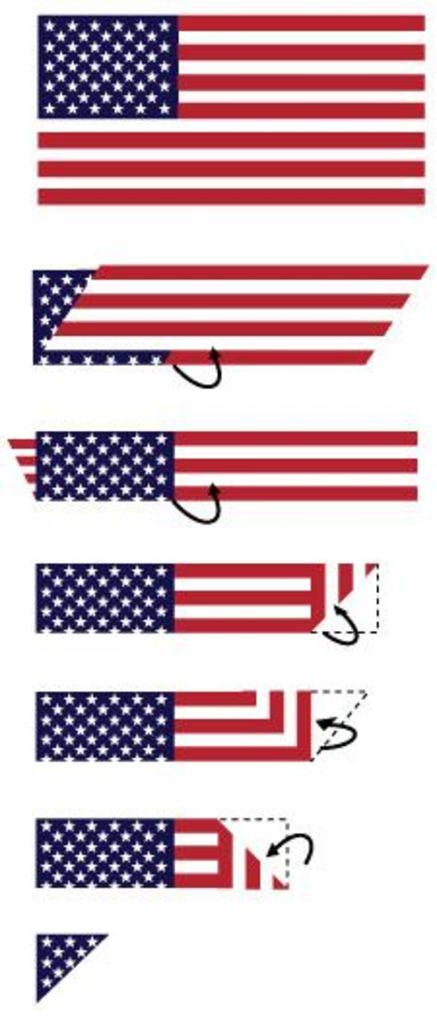What is present in the image that represents a symbol or country? There is a flag in the image. How is the flag designed? The flag is divided into different shapes. What type of scissors can be seen cutting the flag in the image? There are no scissors present in the image, and the flag is not being cut. What type of scarecrow is standing next to the flag in the image? There is no scarecrow present in the image; it only features a flag. 